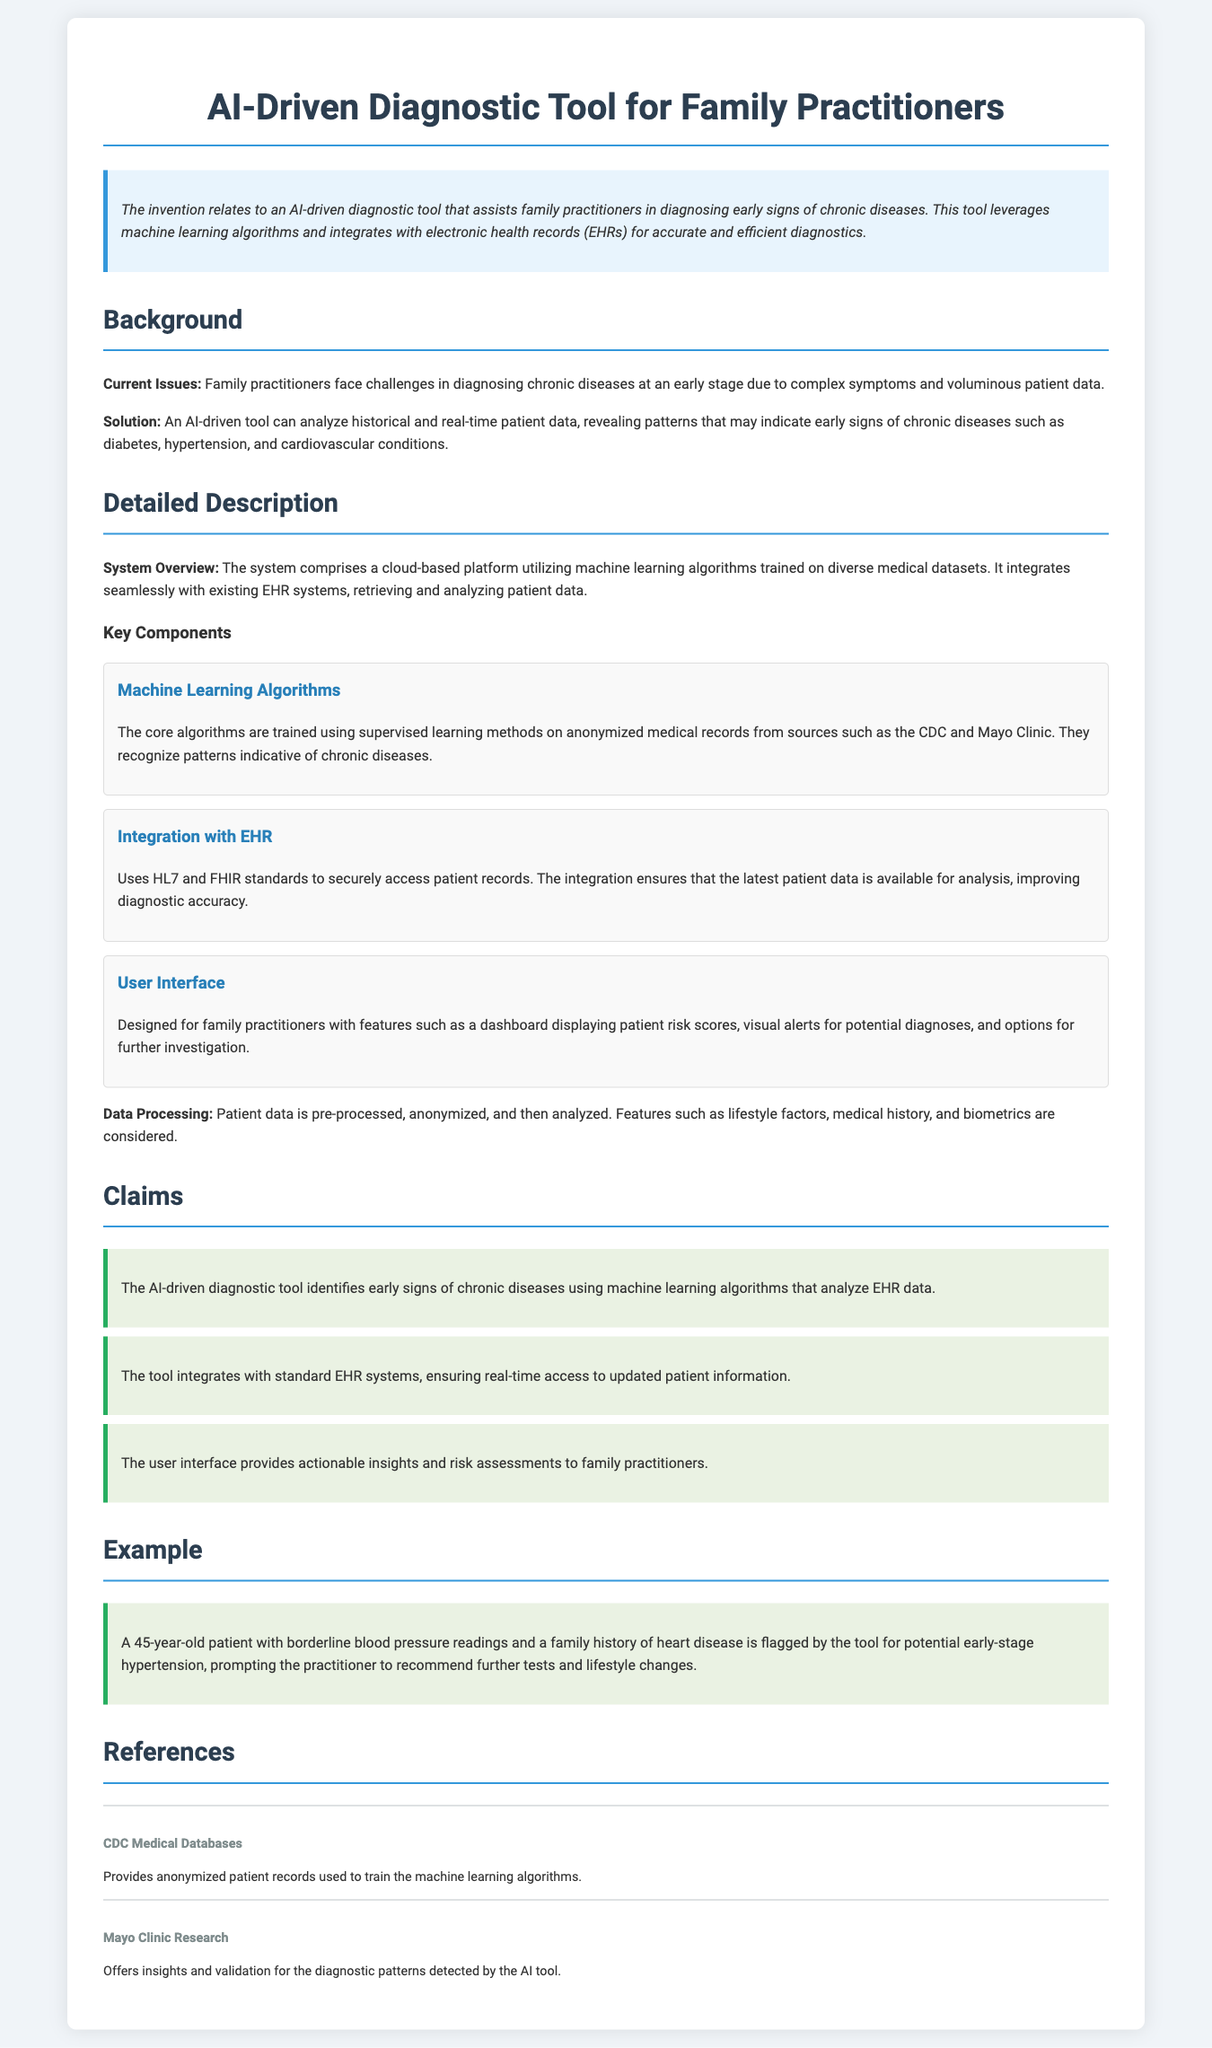What does the invention relate to? The invention relates to an AI-driven diagnostic tool that assists family practitioners in diagnosing early signs of chronic diseases.
Answer: AI-driven diagnostic tool What challenges do family practitioners face? Family practitioners face challenges in diagnosing chronic diseases at an early stage due to complex symptoms and voluminous patient data.
Answer: Complex symptoms and voluminous patient data How does the tool analyze patient data? The tool analyzes historical and real-time patient data, revealing patterns that may indicate early signs of chronic diseases.
Answer: Analyzes historical and real-time patient data What type of learning methods are used for the algorithms? The core algorithms are trained using supervised learning methods.
Answer: Supervised learning methods Which standards does the tool use for integration with EHR? The tool uses HL7 and FHIR standards to securely access patient records.
Answer: HL7 and FHIR standards What key feature does the user interface provide? The user interface provides actionable insights and risk assessments to family practitioners.
Answer: Actionable insights and risk assessments What is the age of the patient in the example? The age of the patient in the example is specified in the document.
Answer: 45 years old Which institutions contributed medical data to train the algorithms? Institutions that contributed medical data are mentioned in the references.
Answer: CDC and Mayo Clinic 